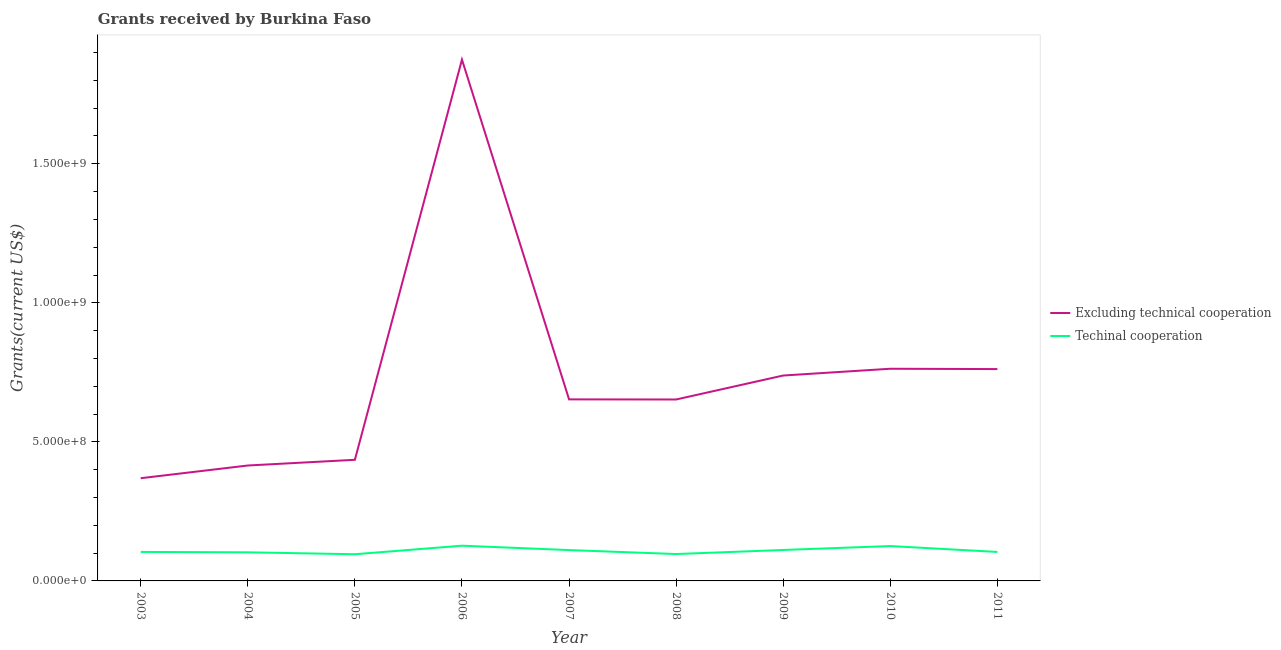Is the number of lines equal to the number of legend labels?
Offer a terse response. Yes. What is the amount of grants received(excluding technical cooperation) in 2008?
Your answer should be compact. 6.52e+08. Across all years, what is the maximum amount of grants received(including technical cooperation)?
Offer a terse response. 1.27e+08. Across all years, what is the minimum amount of grants received(excluding technical cooperation)?
Make the answer very short. 3.69e+08. In which year was the amount of grants received(including technical cooperation) maximum?
Make the answer very short. 2006. What is the total amount of grants received(including technical cooperation) in the graph?
Make the answer very short. 9.78e+08. What is the difference between the amount of grants received(including technical cooperation) in 2008 and that in 2009?
Your response must be concise. -1.46e+07. What is the difference between the amount of grants received(including technical cooperation) in 2003 and the amount of grants received(excluding technical cooperation) in 2007?
Make the answer very short. -5.49e+08. What is the average amount of grants received(excluding technical cooperation) per year?
Your response must be concise. 7.40e+08. In the year 2003, what is the difference between the amount of grants received(excluding technical cooperation) and amount of grants received(including technical cooperation)?
Make the answer very short. 2.65e+08. What is the ratio of the amount of grants received(including technical cooperation) in 2006 to that in 2011?
Ensure brevity in your answer.  1.22. Is the amount of grants received(excluding technical cooperation) in 2003 less than that in 2009?
Offer a very short reply. Yes. What is the difference between the highest and the second highest amount of grants received(excluding technical cooperation)?
Your answer should be compact. 1.11e+09. What is the difference between the highest and the lowest amount of grants received(excluding technical cooperation)?
Make the answer very short. 1.51e+09. In how many years, is the amount of grants received(including technical cooperation) greater than the average amount of grants received(including technical cooperation) taken over all years?
Your answer should be compact. 4. Is the sum of the amount of grants received(excluding technical cooperation) in 2004 and 2009 greater than the maximum amount of grants received(including technical cooperation) across all years?
Provide a succinct answer. Yes. Does the amount of grants received(including technical cooperation) monotonically increase over the years?
Your answer should be compact. No. Is the amount of grants received(including technical cooperation) strictly greater than the amount of grants received(excluding technical cooperation) over the years?
Provide a succinct answer. No. How many lines are there?
Offer a very short reply. 2. How many years are there in the graph?
Provide a short and direct response. 9. What is the difference between two consecutive major ticks on the Y-axis?
Your response must be concise. 5.00e+08. Are the values on the major ticks of Y-axis written in scientific E-notation?
Provide a succinct answer. Yes. Does the graph contain any zero values?
Provide a succinct answer. No. Does the graph contain grids?
Offer a terse response. No. Where does the legend appear in the graph?
Offer a very short reply. Center right. How many legend labels are there?
Keep it short and to the point. 2. How are the legend labels stacked?
Your response must be concise. Vertical. What is the title of the graph?
Offer a terse response. Grants received by Burkina Faso. What is the label or title of the Y-axis?
Your answer should be very brief. Grants(current US$). What is the Grants(current US$) in Excluding technical cooperation in 2003?
Provide a succinct answer. 3.69e+08. What is the Grants(current US$) in Techinal cooperation in 2003?
Your response must be concise. 1.04e+08. What is the Grants(current US$) of Excluding technical cooperation in 2004?
Provide a succinct answer. 4.15e+08. What is the Grants(current US$) in Techinal cooperation in 2004?
Give a very brief answer. 1.03e+08. What is the Grants(current US$) in Excluding technical cooperation in 2005?
Ensure brevity in your answer.  4.36e+08. What is the Grants(current US$) in Techinal cooperation in 2005?
Your answer should be compact. 9.60e+07. What is the Grants(current US$) of Excluding technical cooperation in 2006?
Offer a very short reply. 1.87e+09. What is the Grants(current US$) of Techinal cooperation in 2006?
Provide a succinct answer. 1.27e+08. What is the Grants(current US$) of Excluding technical cooperation in 2007?
Your response must be concise. 6.53e+08. What is the Grants(current US$) of Techinal cooperation in 2007?
Give a very brief answer. 1.11e+08. What is the Grants(current US$) in Excluding technical cooperation in 2008?
Make the answer very short. 6.52e+08. What is the Grants(current US$) in Techinal cooperation in 2008?
Your answer should be compact. 9.67e+07. What is the Grants(current US$) in Excluding technical cooperation in 2009?
Provide a succinct answer. 7.39e+08. What is the Grants(current US$) of Techinal cooperation in 2009?
Your answer should be compact. 1.11e+08. What is the Grants(current US$) in Excluding technical cooperation in 2010?
Provide a short and direct response. 7.63e+08. What is the Grants(current US$) of Techinal cooperation in 2010?
Ensure brevity in your answer.  1.25e+08. What is the Grants(current US$) of Excluding technical cooperation in 2011?
Provide a succinct answer. 7.62e+08. What is the Grants(current US$) in Techinal cooperation in 2011?
Your answer should be compact. 1.04e+08. Across all years, what is the maximum Grants(current US$) of Excluding technical cooperation?
Ensure brevity in your answer.  1.87e+09. Across all years, what is the maximum Grants(current US$) of Techinal cooperation?
Offer a terse response. 1.27e+08. Across all years, what is the minimum Grants(current US$) of Excluding technical cooperation?
Your answer should be compact. 3.69e+08. Across all years, what is the minimum Grants(current US$) of Techinal cooperation?
Offer a very short reply. 9.60e+07. What is the total Grants(current US$) of Excluding technical cooperation in the graph?
Give a very brief answer. 6.66e+09. What is the total Grants(current US$) of Techinal cooperation in the graph?
Provide a short and direct response. 9.78e+08. What is the difference between the Grants(current US$) of Excluding technical cooperation in 2003 and that in 2004?
Your answer should be compact. -4.57e+07. What is the difference between the Grants(current US$) of Techinal cooperation in 2003 and that in 2004?
Your answer should be compact. 1.43e+06. What is the difference between the Grants(current US$) in Excluding technical cooperation in 2003 and that in 2005?
Provide a succinct answer. -6.62e+07. What is the difference between the Grants(current US$) in Techinal cooperation in 2003 and that in 2005?
Your response must be concise. 8.33e+06. What is the difference between the Grants(current US$) in Excluding technical cooperation in 2003 and that in 2006?
Your response must be concise. -1.51e+09. What is the difference between the Grants(current US$) of Techinal cooperation in 2003 and that in 2006?
Offer a very short reply. -2.24e+07. What is the difference between the Grants(current US$) in Excluding technical cooperation in 2003 and that in 2007?
Provide a short and direct response. -2.83e+08. What is the difference between the Grants(current US$) in Techinal cooperation in 2003 and that in 2007?
Provide a succinct answer. -6.62e+06. What is the difference between the Grants(current US$) in Excluding technical cooperation in 2003 and that in 2008?
Your answer should be compact. -2.83e+08. What is the difference between the Grants(current US$) in Techinal cooperation in 2003 and that in 2008?
Provide a succinct answer. 7.61e+06. What is the difference between the Grants(current US$) in Excluding technical cooperation in 2003 and that in 2009?
Give a very brief answer. -3.69e+08. What is the difference between the Grants(current US$) in Techinal cooperation in 2003 and that in 2009?
Ensure brevity in your answer.  -7.01e+06. What is the difference between the Grants(current US$) of Excluding technical cooperation in 2003 and that in 2010?
Keep it short and to the point. -3.94e+08. What is the difference between the Grants(current US$) in Techinal cooperation in 2003 and that in 2010?
Your answer should be compact. -2.11e+07. What is the difference between the Grants(current US$) in Excluding technical cooperation in 2003 and that in 2011?
Keep it short and to the point. -3.92e+08. What is the difference between the Grants(current US$) of Techinal cooperation in 2003 and that in 2011?
Offer a very short reply. 6.00e+04. What is the difference between the Grants(current US$) in Excluding technical cooperation in 2004 and that in 2005?
Offer a terse response. -2.05e+07. What is the difference between the Grants(current US$) in Techinal cooperation in 2004 and that in 2005?
Your answer should be very brief. 6.90e+06. What is the difference between the Grants(current US$) of Excluding technical cooperation in 2004 and that in 2006?
Offer a very short reply. -1.46e+09. What is the difference between the Grants(current US$) in Techinal cooperation in 2004 and that in 2006?
Keep it short and to the point. -2.38e+07. What is the difference between the Grants(current US$) of Excluding technical cooperation in 2004 and that in 2007?
Your answer should be very brief. -2.38e+08. What is the difference between the Grants(current US$) in Techinal cooperation in 2004 and that in 2007?
Your answer should be compact. -8.05e+06. What is the difference between the Grants(current US$) of Excluding technical cooperation in 2004 and that in 2008?
Keep it short and to the point. -2.37e+08. What is the difference between the Grants(current US$) in Techinal cooperation in 2004 and that in 2008?
Offer a very short reply. 6.18e+06. What is the difference between the Grants(current US$) of Excluding technical cooperation in 2004 and that in 2009?
Offer a very short reply. -3.24e+08. What is the difference between the Grants(current US$) of Techinal cooperation in 2004 and that in 2009?
Your response must be concise. -8.44e+06. What is the difference between the Grants(current US$) in Excluding technical cooperation in 2004 and that in 2010?
Offer a terse response. -3.48e+08. What is the difference between the Grants(current US$) of Techinal cooperation in 2004 and that in 2010?
Keep it short and to the point. -2.25e+07. What is the difference between the Grants(current US$) of Excluding technical cooperation in 2004 and that in 2011?
Your answer should be compact. -3.47e+08. What is the difference between the Grants(current US$) in Techinal cooperation in 2004 and that in 2011?
Offer a terse response. -1.37e+06. What is the difference between the Grants(current US$) in Excluding technical cooperation in 2005 and that in 2006?
Ensure brevity in your answer.  -1.44e+09. What is the difference between the Grants(current US$) in Techinal cooperation in 2005 and that in 2006?
Offer a terse response. -3.07e+07. What is the difference between the Grants(current US$) of Excluding technical cooperation in 2005 and that in 2007?
Your response must be concise. -2.17e+08. What is the difference between the Grants(current US$) in Techinal cooperation in 2005 and that in 2007?
Make the answer very short. -1.50e+07. What is the difference between the Grants(current US$) in Excluding technical cooperation in 2005 and that in 2008?
Offer a terse response. -2.17e+08. What is the difference between the Grants(current US$) of Techinal cooperation in 2005 and that in 2008?
Keep it short and to the point. -7.20e+05. What is the difference between the Grants(current US$) in Excluding technical cooperation in 2005 and that in 2009?
Ensure brevity in your answer.  -3.03e+08. What is the difference between the Grants(current US$) in Techinal cooperation in 2005 and that in 2009?
Offer a very short reply. -1.53e+07. What is the difference between the Grants(current US$) in Excluding technical cooperation in 2005 and that in 2010?
Your answer should be compact. -3.27e+08. What is the difference between the Grants(current US$) in Techinal cooperation in 2005 and that in 2010?
Your answer should be compact. -2.94e+07. What is the difference between the Grants(current US$) in Excluding technical cooperation in 2005 and that in 2011?
Give a very brief answer. -3.26e+08. What is the difference between the Grants(current US$) in Techinal cooperation in 2005 and that in 2011?
Your answer should be very brief. -8.27e+06. What is the difference between the Grants(current US$) in Excluding technical cooperation in 2006 and that in 2007?
Your answer should be very brief. 1.22e+09. What is the difference between the Grants(current US$) in Techinal cooperation in 2006 and that in 2007?
Offer a terse response. 1.58e+07. What is the difference between the Grants(current US$) in Excluding technical cooperation in 2006 and that in 2008?
Keep it short and to the point. 1.22e+09. What is the difference between the Grants(current US$) in Techinal cooperation in 2006 and that in 2008?
Provide a succinct answer. 3.00e+07. What is the difference between the Grants(current US$) in Excluding technical cooperation in 2006 and that in 2009?
Offer a very short reply. 1.14e+09. What is the difference between the Grants(current US$) of Techinal cooperation in 2006 and that in 2009?
Offer a very short reply. 1.54e+07. What is the difference between the Grants(current US$) of Excluding technical cooperation in 2006 and that in 2010?
Offer a very short reply. 1.11e+09. What is the difference between the Grants(current US$) in Techinal cooperation in 2006 and that in 2010?
Ensure brevity in your answer.  1.30e+06. What is the difference between the Grants(current US$) in Excluding technical cooperation in 2006 and that in 2011?
Offer a terse response. 1.11e+09. What is the difference between the Grants(current US$) of Techinal cooperation in 2006 and that in 2011?
Make the answer very short. 2.24e+07. What is the difference between the Grants(current US$) in Excluding technical cooperation in 2007 and that in 2008?
Make the answer very short. 4.10e+05. What is the difference between the Grants(current US$) of Techinal cooperation in 2007 and that in 2008?
Keep it short and to the point. 1.42e+07. What is the difference between the Grants(current US$) in Excluding technical cooperation in 2007 and that in 2009?
Ensure brevity in your answer.  -8.58e+07. What is the difference between the Grants(current US$) of Techinal cooperation in 2007 and that in 2009?
Make the answer very short. -3.90e+05. What is the difference between the Grants(current US$) of Excluding technical cooperation in 2007 and that in 2010?
Ensure brevity in your answer.  -1.10e+08. What is the difference between the Grants(current US$) of Techinal cooperation in 2007 and that in 2010?
Ensure brevity in your answer.  -1.45e+07. What is the difference between the Grants(current US$) of Excluding technical cooperation in 2007 and that in 2011?
Offer a terse response. -1.09e+08. What is the difference between the Grants(current US$) of Techinal cooperation in 2007 and that in 2011?
Offer a terse response. 6.68e+06. What is the difference between the Grants(current US$) of Excluding technical cooperation in 2008 and that in 2009?
Ensure brevity in your answer.  -8.62e+07. What is the difference between the Grants(current US$) of Techinal cooperation in 2008 and that in 2009?
Provide a succinct answer. -1.46e+07. What is the difference between the Grants(current US$) of Excluding technical cooperation in 2008 and that in 2010?
Make the answer very short. -1.11e+08. What is the difference between the Grants(current US$) in Techinal cooperation in 2008 and that in 2010?
Make the answer very short. -2.87e+07. What is the difference between the Grants(current US$) of Excluding technical cooperation in 2008 and that in 2011?
Ensure brevity in your answer.  -1.09e+08. What is the difference between the Grants(current US$) in Techinal cooperation in 2008 and that in 2011?
Give a very brief answer. -7.55e+06. What is the difference between the Grants(current US$) of Excluding technical cooperation in 2009 and that in 2010?
Your answer should be compact. -2.43e+07. What is the difference between the Grants(current US$) in Techinal cooperation in 2009 and that in 2010?
Offer a very short reply. -1.41e+07. What is the difference between the Grants(current US$) of Excluding technical cooperation in 2009 and that in 2011?
Give a very brief answer. -2.32e+07. What is the difference between the Grants(current US$) of Techinal cooperation in 2009 and that in 2011?
Your answer should be very brief. 7.07e+06. What is the difference between the Grants(current US$) in Excluding technical cooperation in 2010 and that in 2011?
Provide a succinct answer. 1.18e+06. What is the difference between the Grants(current US$) of Techinal cooperation in 2010 and that in 2011?
Offer a very short reply. 2.12e+07. What is the difference between the Grants(current US$) in Excluding technical cooperation in 2003 and the Grants(current US$) in Techinal cooperation in 2004?
Offer a terse response. 2.66e+08. What is the difference between the Grants(current US$) of Excluding technical cooperation in 2003 and the Grants(current US$) of Techinal cooperation in 2005?
Keep it short and to the point. 2.73e+08. What is the difference between the Grants(current US$) in Excluding technical cooperation in 2003 and the Grants(current US$) in Techinal cooperation in 2006?
Provide a short and direct response. 2.43e+08. What is the difference between the Grants(current US$) in Excluding technical cooperation in 2003 and the Grants(current US$) in Techinal cooperation in 2007?
Your answer should be very brief. 2.58e+08. What is the difference between the Grants(current US$) in Excluding technical cooperation in 2003 and the Grants(current US$) in Techinal cooperation in 2008?
Give a very brief answer. 2.73e+08. What is the difference between the Grants(current US$) in Excluding technical cooperation in 2003 and the Grants(current US$) in Techinal cooperation in 2009?
Your answer should be very brief. 2.58e+08. What is the difference between the Grants(current US$) of Excluding technical cooperation in 2003 and the Grants(current US$) of Techinal cooperation in 2010?
Provide a succinct answer. 2.44e+08. What is the difference between the Grants(current US$) in Excluding technical cooperation in 2003 and the Grants(current US$) in Techinal cooperation in 2011?
Ensure brevity in your answer.  2.65e+08. What is the difference between the Grants(current US$) of Excluding technical cooperation in 2004 and the Grants(current US$) of Techinal cooperation in 2005?
Keep it short and to the point. 3.19e+08. What is the difference between the Grants(current US$) of Excluding technical cooperation in 2004 and the Grants(current US$) of Techinal cooperation in 2006?
Offer a terse response. 2.88e+08. What is the difference between the Grants(current US$) in Excluding technical cooperation in 2004 and the Grants(current US$) in Techinal cooperation in 2007?
Give a very brief answer. 3.04e+08. What is the difference between the Grants(current US$) of Excluding technical cooperation in 2004 and the Grants(current US$) of Techinal cooperation in 2008?
Offer a terse response. 3.18e+08. What is the difference between the Grants(current US$) of Excluding technical cooperation in 2004 and the Grants(current US$) of Techinal cooperation in 2009?
Keep it short and to the point. 3.04e+08. What is the difference between the Grants(current US$) of Excluding technical cooperation in 2004 and the Grants(current US$) of Techinal cooperation in 2010?
Provide a succinct answer. 2.90e+08. What is the difference between the Grants(current US$) of Excluding technical cooperation in 2004 and the Grants(current US$) of Techinal cooperation in 2011?
Provide a succinct answer. 3.11e+08. What is the difference between the Grants(current US$) of Excluding technical cooperation in 2005 and the Grants(current US$) of Techinal cooperation in 2006?
Provide a short and direct response. 3.09e+08. What is the difference between the Grants(current US$) in Excluding technical cooperation in 2005 and the Grants(current US$) in Techinal cooperation in 2007?
Make the answer very short. 3.25e+08. What is the difference between the Grants(current US$) in Excluding technical cooperation in 2005 and the Grants(current US$) in Techinal cooperation in 2008?
Make the answer very short. 3.39e+08. What is the difference between the Grants(current US$) in Excluding technical cooperation in 2005 and the Grants(current US$) in Techinal cooperation in 2009?
Your response must be concise. 3.24e+08. What is the difference between the Grants(current US$) in Excluding technical cooperation in 2005 and the Grants(current US$) in Techinal cooperation in 2010?
Ensure brevity in your answer.  3.10e+08. What is the difference between the Grants(current US$) in Excluding technical cooperation in 2005 and the Grants(current US$) in Techinal cooperation in 2011?
Offer a terse response. 3.31e+08. What is the difference between the Grants(current US$) in Excluding technical cooperation in 2006 and the Grants(current US$) in Techinal cooperation in 2007?
Your answer should be compact. 1.76e+09. What is the difference between the Grants(current US$) in Excluding technical cooperation in 2006 and the Grants(current US$) in Techinal cooperation in 2008?
Your answer should be compact. 1.78e+09. What is the difference between the Grants(current US$) in Excluding technical cooperation in 2006 and the Grants(current US$) in Techinal cooperation in 2009?
Provide a short and direct response. 1.76e+09. What is the difference between the Grants(current US$) of Excluding technical cooperation in 2006 and the Grants(current US$) of Techinal cooperation in 2010?
Give a very brief answer. 1.75e+09. What is the difference between the Grants(current US$) of Excluding technical cooperation in 2006 and the Grants(current US$) of Techinal cooperation in 2011?
Offer a terse response. 1.77e+09. What is the difference between the Grants(current US$) in Excluding technical cooperation in 2007 and the Grants(current US$) in Techinal cooperation in 2008?
Offer a very short reply. 5.56e+08. What is the difference between the Grants(current US$) of Excluding technical cooperation in 2007 and the Grants(current US$) of Techinal cooperation in 2009?
Offer a very short reply. 5.42e+08. What is the difference between the Grants(current US$) in Excluding technical cooperation in 2007 and the Grants(current US$) in Techinal cooperation in 2010?
Provide a short and direct response. 5.27e+08. What is the difference between the Grants(current US$) in Excluding technical cooperation in 2007 and the Grants(current US$) in Techinal cooperation in 2011?
Your response must be concise. 5.49e+08. What is the difference between the Grants(current US$) in Excluding technical cooperation in 2008 and the Grants(current US$) in Techinal cooperation in 2009?
Keep it short and to the point. 5.41e+08. What is the difference between the Grants(current US$) in Excluding technical cooperation in 2008 and the Grants(current US$) in Techinal cooperation in 2010?
Give a very brief answer. 5.27e+08. What is the difference between the Grants(current US$) of Excluding technical cooperation in 2008 and the Grants(current US$) of Techinal cooperation in 2011?
Offer a terse response. 5.48e+08. What is the difference between the Grants(current US$) of Excluding technical cooperation in 2009 and the Grants(current US$) of Techinal cooperation in 2010?
Keep it short and to the point. 6.13e+08. What is the difference between the Grants(current US$) in Excluding technical cooperation in 2009 and the Grants(current US$) in Techinal cooperation in 2011?
Provide a short and direct response. 6.34e+08. What is the difference between the Grants(current US$) in Excluding technical cooperation in 2010 and the Grants(current US$) in Techinal cooperation in 2011?
Your answer should be very brief. 6.59e+08. What is the average Grants(current US$) in Excluding technical cooperation per year?
Offer a terse response. 7.40e+08. What is the average Grants(current US$) in Techinal cooperation per year?
Your answer should be compact. 1.09e+08. In the year 2003, what is the difference between the Grants(current US$) in Excluding technical cooperation and Grants(current US$) in Techinal cooperation?
Offer a terse response. 2.65e+08. In the year 2004, what is the difference between the Grants(current US$) of Excluding technical cooperation and Grants(current US$) of Techinal cooperation?
Ensure brevity in your answer.  3.12e+08. In the year 2005, what is the difference between the Grants(current US$) of Excluding technical cooperation and Grants(current US$) of Techinal cooperation?
Offer a terse response. 3.40e+08. In the year 2006, what is the difference between the Grants(current US$) of Excluding technical cooperation and Grants(current US$) of Techinal cooperation?
Your response must be concise. 1.75e+09. In the year 2007, what is the difference between the Grants(current US$) in Excluding technical cooperation and Grants(current US$) in Techinal cooperation?
Give a very brief answer. 5.42e+08. In the year 2008, what is the difference between the Grants(current US$) of Excluding technical cooperation and Grants(current US$) of Techinal cooperation?
Provide a short and direct response. 5.56e+08. In the year 2009, what is the difference between the Grants(current US$) in Excluding technical cooperation and Grants(current US$) in Techinal cooperation?
Your response must be concise. 6.27e+08. In the year 2010, what is the difference between the Grants(current US$) of Excluding technical cooperation and Grants(current US$) of Techinal cooperation?
Offer a very short reply. 6.38e+08. In the year 2011, what is the difference between the Grants(current US$) in Excluding technical cooperation and Grants(current US$) in Techinal cooperation?
Keep it short and to the point. 6.58e+08. What is the ratio of the Grants(current US$) of Excluding technical cooperation in 2003 to that in 2004?
Your response must be concise. 0.89. What is the ratio of the Grants(current US$) of Techinal cooperation in 2003 to that in 2004?
Provide a short and direct response. 1.01. What is the ratio of the Grants(current US$) in Excluding technical cooperation in 2003 to that in 2005?
Your answer should be very brief. 0.85. What is the ratio of the Grants(current US$) of Techinal cooperation in 2003 to that in 2005?
Give a very brief answer. 1.09. What is the ratio of the Grants(current US$) in Excluding technical cooperation in 2003 to that in 2006?
Keep it short and to the point. 0.2. What is the ratio of the Grants(current US$) in Techinal cooperation in 2003 to that in 2006?
Keep it short and to the point. 0.82. What is the ratio of the Grants(current US$) of Excluding technical cooperation in 2003 to that in 2007?
Keep it short and to the point. 0.57. What is the ratio of the Grants(current US$) in Techinal cooperation in 2003 to that in 2007?
Your answer should be compact. 0.94. What is the ratio of the Grants(current US$) of Excluding technical cooperation in 2003 to that in 2008?
Provide a short and direct response. 0.57. What is the ratio of the Grants(current US$) in Techinal cooperation in 2003 to that in 2008?
Your response must be concise. 1.08. What is the ratio of the Grants(current US$) of Techinal cooperation in 2003 to that in 2009?
Your answer should be very brief. 0.94. What is the ratio of the Grants(current US$) of Excluding technical cooperation in 2003 to that in 2010?
Offer a very short reply. 0.48. What is the ratio of the Grants(current US$) of Techinal cooperation in 2003 to that in 2010?
Your answer should be very brief. 0.83. What is the ratio of the Grants(current US$) of Excluding technical cooperation in 2003 to that in 2011?
Make the answer very short. 0.48. What is the ratio of the Grants(current US$) of Techinal cooperation in 2003 to that in 2011?
Provide a short and direct response. 1. What is the ratio of the Grants(current US$) in Excluding technical cooperation in 2004 to that in 2005?
Your answer should be compact. 0.95. What is the ratio of the Grants(current US$) of Techinal cooperation in 2004 to that in 2005?
Provide a short and direct response. 1.07. What is the ratio of the Grants(current US$) in Excluding technical cooperation in 2004 to that in 2006?
Ensure brevity in your answer.  0.22. What is the ratio of the Grants(current US$) of Techinal cooperation in 2004 to that in 2006?
Provide a short and direct response. 0.81. What is the ratio of the Grants(current US$) in Excluding technical cooperation in 2004 to that in 2007?
Provide a succinct answer. 0.64. What is the ratio of the Grants(current US$) in Techinal cooperation in 2004 to that in 2007?
Provide a short and direct response. 0.93. What is the ratio of the Grants(current US$) of Excluding technical cooperation in 2004 to that in 2008?
Your answer should be very brief. 0.64. What is the ratio of the Grants(current US$) of Techinal cooperation in 2004 to that in 2008?
Offer a very short reply. 1.06. What is the ratio of the Grants(current US$) of Excluding technical cooperation in 2004 to that in 2009?
Your answer should be compact. 0.56. What is the ratio of the Grants(current US$) in Techinal cooperation in 2004 to that in 2009?
Ensure brevity in your answer.  0.92. What is the ratio of the Grants(current US$) of Excluding technical cooperation in 2004 to that in 2010?
Your answer should be very brief. 0.54. What is the ratio of the Grants(current US$) of Techinal cooperation in 2004 to that in 2010?
Offer a very short reply. 0.82. What is the ratio of the Grants(current US$) in Excluding technical cooperation in 2004 to that in 2011?
Your response must be concise. 0.54. What is the ratio of the Grants(current US$) of Techinal cooperation in 2004 to that in 2011?
Give a very brief answer. 0.99. What is the ratio of the Grants(current US$) in Excluding technical cooperation in 2005 to that in 2006?
Give a very brief answer. 0.23. What is the ratio of the Grants(current US$) in Techinal cooperation in 2005 to that in 2006?
Your answer should be compact. 0.76. What is the ratio of the Grants(current US$) in Excluding technical cooperation in 2005 to that in 2007?
Your answer should be very brief. 0.67. What is the ratio of the Grants(current US$) of Techinal cooperation in 2005 to that in 2007?
Offer a very short reply. 0.87. What is the ratio of the Grants(current US$) of Excluding technical cooperation in 2005 to that in 2008?
Provide a succinct answer. 0.67. What is the ratio of the Grants(current US$) of Techinal cooperation in 2005 to that in 2008?
Your answer should be very brief. 0.99. What is the ratio of the Grants(current US$) in Excluding technical cooperation in 2005 to that in 2009?
Offer a terse response. 0.59. What is the ratio of the Grants(current US$) in Techinal cooperation in 2005 to that in 2009?
Keep it short and to the point. 0.86. What is the ratio of the Grants(current US$) of Excluding technical cooperation in 2005 to that in 2010?
Provide a short and direct response. 0.57. What is the ratio of the Grants(current US$) of Techinal cooperation in 2005 to that in 2010?
Your answer should be very brief. 0.77. What is the ratio of the Grants(current US$) in Excluding technical cooperation in 2005 to that in 2011?
Your answer should be compact. 0.57. What is the ratio of the Grants(current US$) of Techinal cooperation in 2005 to that in 2011?
Offer a terse response. 0.92. What is the ratio of the Grants(current US$) of Excluding technical cooperation in 2006 to that in 2007?
Provide a short and direct response. 2.87. What is the ratio of the Grants(current US$) in Techinal cooperation in 2006 to that in 2007?
Offer a very short reply. 1.14. What is the ratio of the Grants(current US$) in Excluding technical cooperation in 2006 to that in 2008?
Make the answer very short. 2.87. What is the ratio of the Grants(current US$) of Techinal cooperation in 2006 to that in 2008?
Your response must be concise. 1.31. What is the ratio of the Grants(current US$) in Excluding technical cooperation in 2006 to that in 2009?
Your answer should be compact. 2.54. What is the ratio of the Grants(current US$) of Techinal cooperation in 2006 to that in 2009?
Provide a short and direct response. 1.14. What is the ratio of the Grants(current US$) of Excluding technical cooperation in 2006 to that in 2010?
Give a very brief answer. 2.46. What is the ratio of the Grants(current US$) of Techinal cooperation in 2006 to that in 2010?
Provide a succinct answer. 1.01. What is the ratio of the Grants(current US$) in Excluding technical cooperation in 2006 to that in 2011?
Provide a succinct answer. 2.46. What is the ratio of the Grants(current US$) of Techinal cooperation in 2006 to that in 2011?
Provide a short and direct response. 1.22. What is the ratio of the Grants(current US$) in Excluding technical cooperation in 2007 to that in 2008?
Ensure brevity in your answer.  1. What is the ratio of the Grants(current US$) of Techinal cooperation in 2007 to that in 2008?
Offer a terse response. 1.15. What is the ratio of the Grants(current US$) of Excluding technical cooperation in 2007 to that in 2009?
Provide a succinct answer. 0.88. What is the ratio of the Grants(current US$) of Techinal cooperation in 2007 to that in 2009?
Ensure brevity in your answer.  1. What is the ratio of the Grants(current US$) of Excluding technical cooperation in 2007 to that in 2010?
Make the answer very short. 0.86. What is the ratio of the Grants(current US$) in Techinal cooperation in 2007 to that in 2010?
Your answer should be compact. 0.88. What is the ratio of the Grants(current US$) of Excluding technical cooperation in 2007 to that in 2011?
Ensure brevity in your answer.  0.86. What is the ratio of the Grants(current US$) in Techinal cooperation in 2007 to that in 2011?
Offer a very short reply. 1.06. What is the ratio of the Grants(current US$) of Excluding technical cooperation in 2008 to that in 2009?
Offer a very short reply. 0.88. What is the ratio of the Grants(current US$) of Techinal cooperation in 2008 to that in 2009?
Provide a short and direct response. 0.87. What is the ratio of the Grants(current US$) in Excluding technical cooperation in 2008 to that in 2010?
Give a very brief answer. 0.86. What is the ratio of the Grants(current US$) of Techinal cooperation in 2008 to that in 2010?
Provide a succinct answer. 0.77. What is the ratio of the Grants(current US$) of Excluding technical cooperation in 2008 to that in 2011?
Your answer should be very brief. 0.86. What is the ratio of the Grants(current US$) of Techinal cooperation in 2008 to that in 2011?
Your answer should be very brief. 0.93. What is the ratio of the Grants(current US$) in Excluding technical cooperation in 2009 to that in 2010?
Your response must be concise. 0.97. What is the ratio of the Grants(current US$) of Techinal cooperation in 2009 to that in 2010?
Offer a terse response. 0.89. What is the ratio of the Grants(current US$) of Excluding technical cooperation in 2009 to that in 2011?
Your answer should be very brief. 0.97. What is the ratio of the Grants(current US$) of Techinal cooperation in 2009 to that in 2011?
Offer a very short reply. 1.07. What is the ratio of the Grants(current US$) in Techinal cooperation in 2010 to that in 2011?
Your response must be concise. 1.2. What is the difference between the highest and the second highest Grants(current US$) of Excluding technical cooperation?
Make the answer very short. 1.11e+09. What is the difference between the highest and the second highest Grants(current US$) of Techinal cooperation?
Provide a short and direct response. 1.30e+06. What is the difference between the highest and the lowest Grants(current US$) in Excluding technical cooperation?
Offer a very short reply. 1.51e+09. What is the difference between the highest and the lowest Grants(current US$) of Techinal cooperation?
Offer a very short reply. 3.07e+07. 